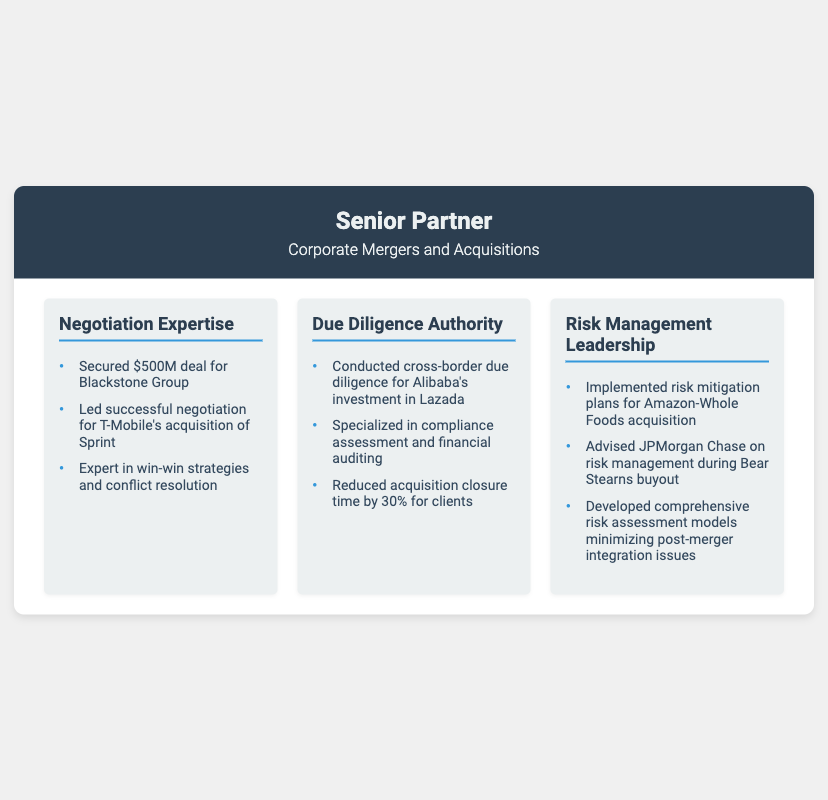What is the title under the name? The title under the name in the header section of the business card is specified as "Corporate Mergers and Acquisitions".
Answer: Corporate Mergers and Acquisitions How much was the secured deal for Blackstone Group? The amount of the secured deal mentioned in the document for the Blackstone Group is clearly stated in the negotiation section.
Answer: $500M Which company acquired Sprint? The company that led the successful negotiation for the acquisition of Sprint is mentioned explicitly.
Answer: T-Mobile What percentage did the due diligence reduce the acquisition closure time by? The document specifies a percentage related to the efficiency achieved through due diligence activities.
Answer: 30% Which acquisition involved risk mitigation plans? The acquisition that involved the implementation of risk mitigation plans is noted in the risk management section.
Answer: Amazon-Whole Foods What role did the individual advise JPMorgan Chase on during the Bear Stearns buyout? The document indicates a specific focus area regarding risk management during the Bear Stearns buyout in the risk management section.
Answer: Risk Management What is the expertise highlighted in the second strength? The second strength in the core strengths section specifically highlights a particular area of expertise.
Answer: Due Diligence How many strengths are listed in total? The total number of core strengths mentioned on the business card can be counted based on the sections displayed.
Answer: Three 